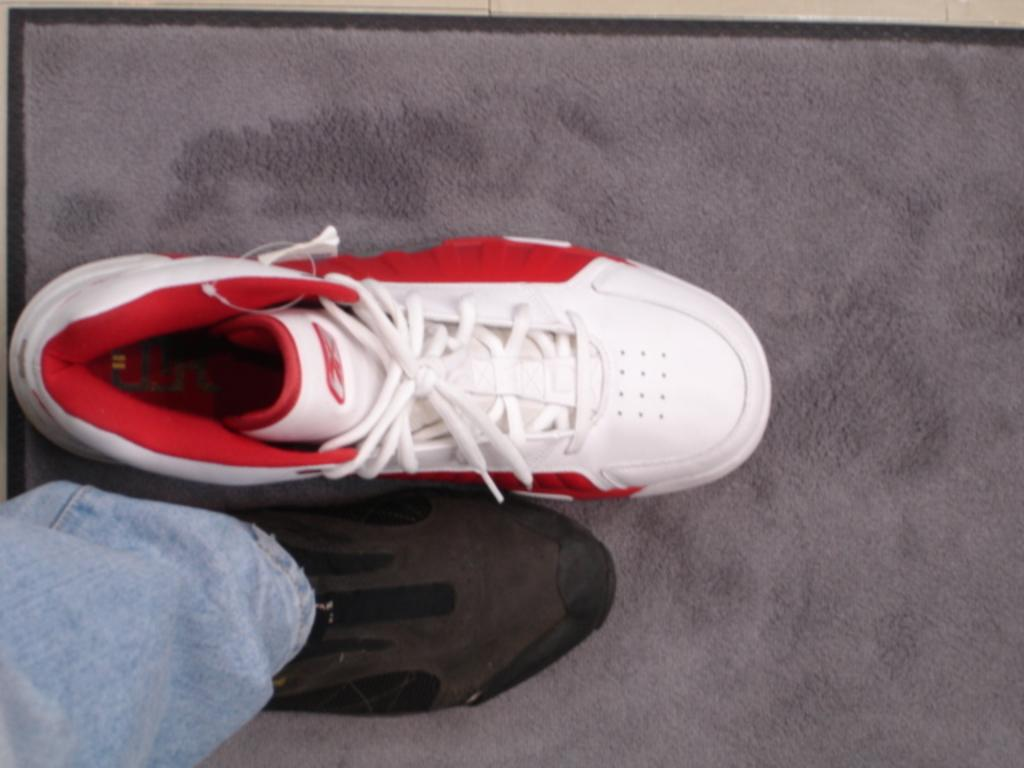What color shoes can be seen in the image? There is a white and red color shoe and a black color shoe in the image. Where are the shoes placed in the image? Both shoes are placed on a grey floor mat. What type of clothing is visible in the image? There is a blue color jean pant in the image. Where is the blue jean pant located in the image? The blue jean pant is on the grey floor mat. How many pizzas are being served on the whip in the image? There are no pizzas or whips present in the image. 